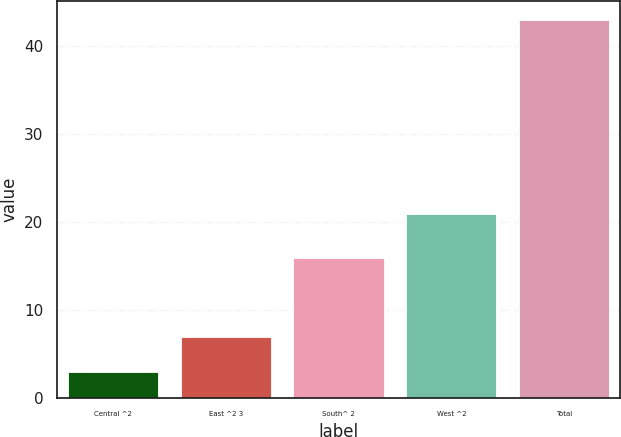Convert chart to OTSL. <chart><loc_0><loc_0><loc_500><loc_500><bar_chart><fcel>Central ^2<fcel>East ^2 3<fcel>South^ 2<fcel>West ^2<fcel>Total<nl><fcel>3<fcel>7<fcel>16<fcel>21<fcel>43<nl></chart> 